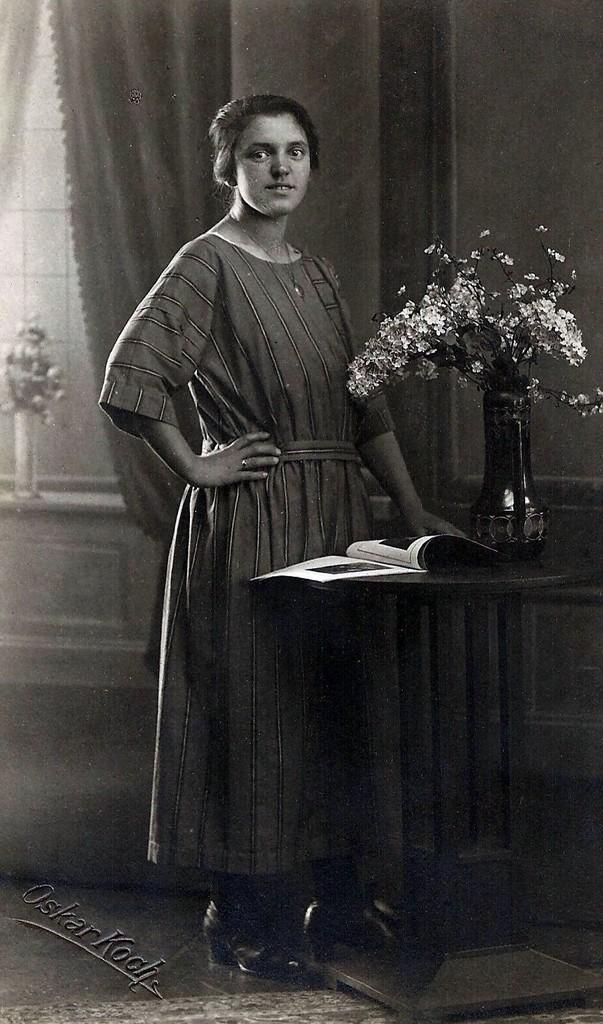What is the lady in the image doing? The lady is standing in the image. What is in front of the lady? There is a table in front of the lady. What objects are on the table? There is a book and two vases on the table. What can be seen behind the lady? There is a curtain behind the lady. How many kittens are playing with the meat in the middle of the table? There are no kittens or meat present in the image. 